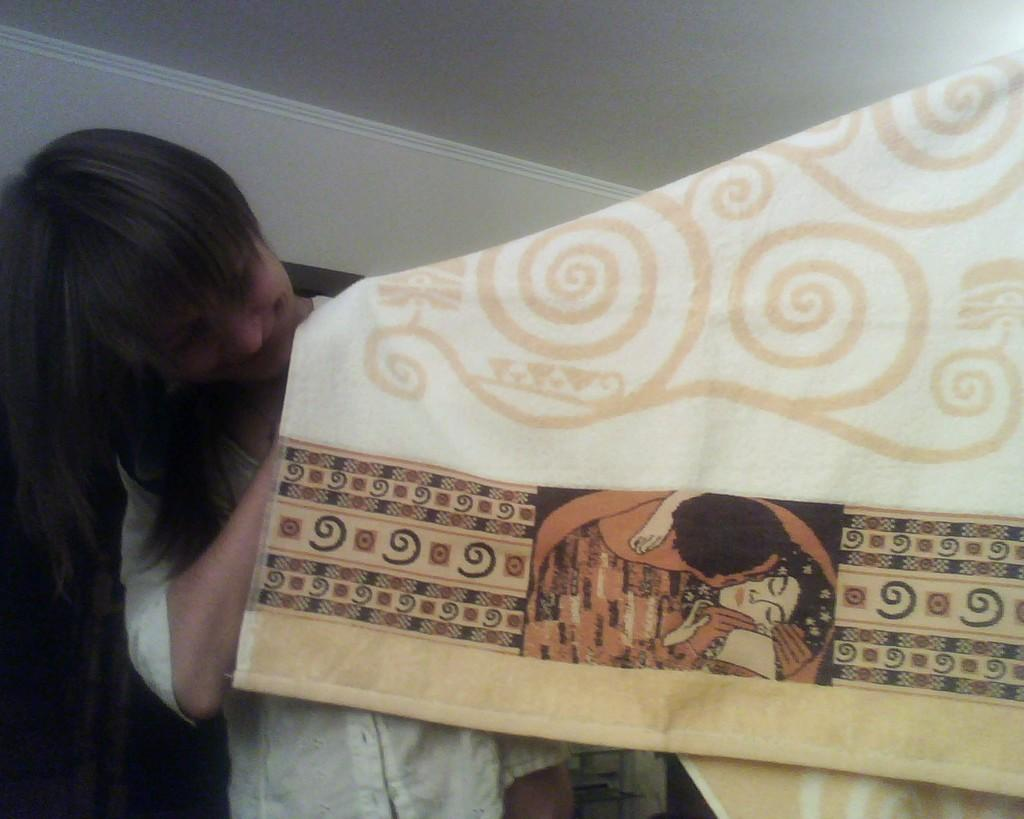Who or what is present in the image? There is a person in the image. What structure can be seen above the person? There is a roof in the image. What object is visible in the image, separate from the person and roof? There is a cloth in the image. What type of chin is visible on the person in the image? There is no chin visible on the person in the image, as the person is not shown in a way that reveals their chin. 